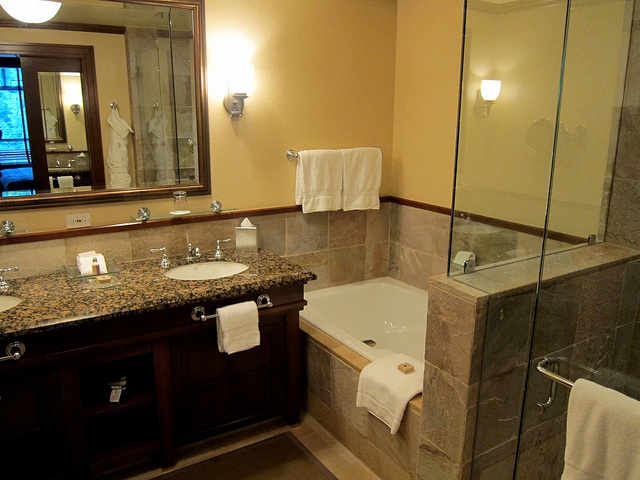Describe the objects in this image and their specific colors. I can see sink in white, tan, and olive tones, sink in white, tan, and olive tones, and cup in white, tan, olive, and beige tones in this image. 